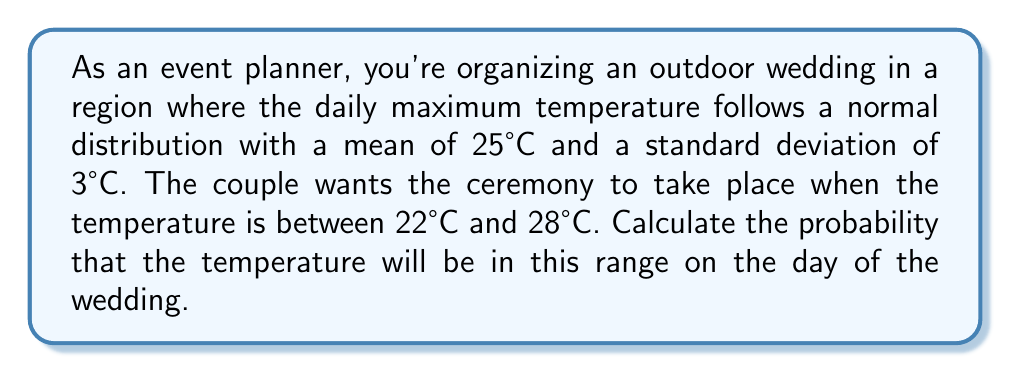Provide a solution to this math problem. To solve this problem, we need to use the probability density function (PDF) of the normal distribution and calculate the area under the curve between 22°C and 28°C. We'll use the standard normal distribution (z-score) to simplify our calculations.

Step 1: Calculate the z-scores for the lower and upper bounds of the temperature range.

For the lower bound (22°C):
$$ z_1 = \frac{22 - 25}{3} = -1 $$

For the upper bound (28°C):
$$ z_2 = \frac{28 - 25}{3} = 1 $$

Step 2: Use the standard normal distribution table or a calculator to find the area under the curve between these z-scores.

The probability is equal to the area between z = -1 and z = 1 in the standard normal distribution.

$$ P(-1 \leq Z \leq 1) = P(Z \leq 1) - P(Z \leq -1) $$

Using a standard normal distribution table or calculator:

$$ P(Z \leq 1) \approx 0.8413 $$
$$ P(Z \leq -1) \approx 0.1587 $$

Step 3: Calculate the final probability.

$$ P(-1 \leq Z \leq 1) = 0.8413 - 0.1587 = 0.6826 $$

Therefore, the probability that the temperature will be between 22°C and 28°C on the day of the wedding is approximately 0.6826 or 68.26%.
Answer: The probability that the temperature will be between 22°C and 28°C on the day of the wedding is approximately 0.6826 or 68.26%. 